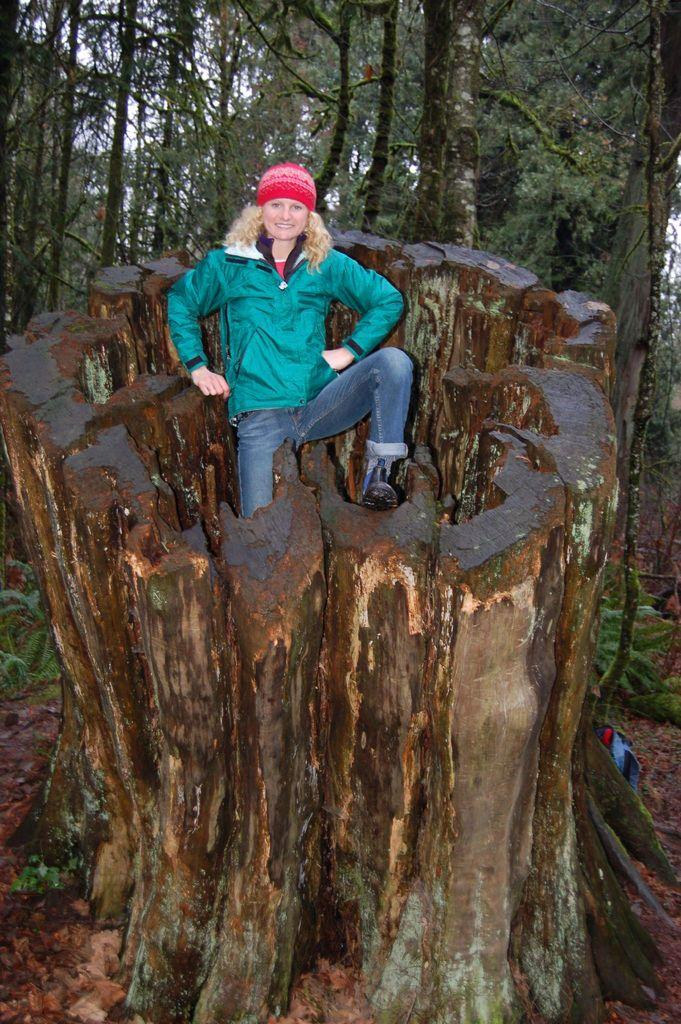What is the main subject of the image? There is a woman in the image. What is the woman doing in the image? The woman is standing and smiling. Where is the woman standing in the image? The woman appears to be standing on a tree trunk. What can be seen in the background of the image? There are trees with branches and leaves in the image. What type of scarf is the beast wearing in the image? There is no beast or scarf present in the image. Can you solve the riddle that the woman is holding in the image? There is no riddle present in the image. 